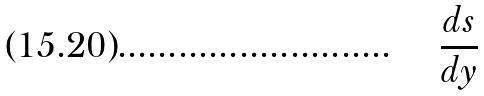<formula> <loc_0><loc_0><loc_500><loc_500>\frac { d s } { d y }</formula> 